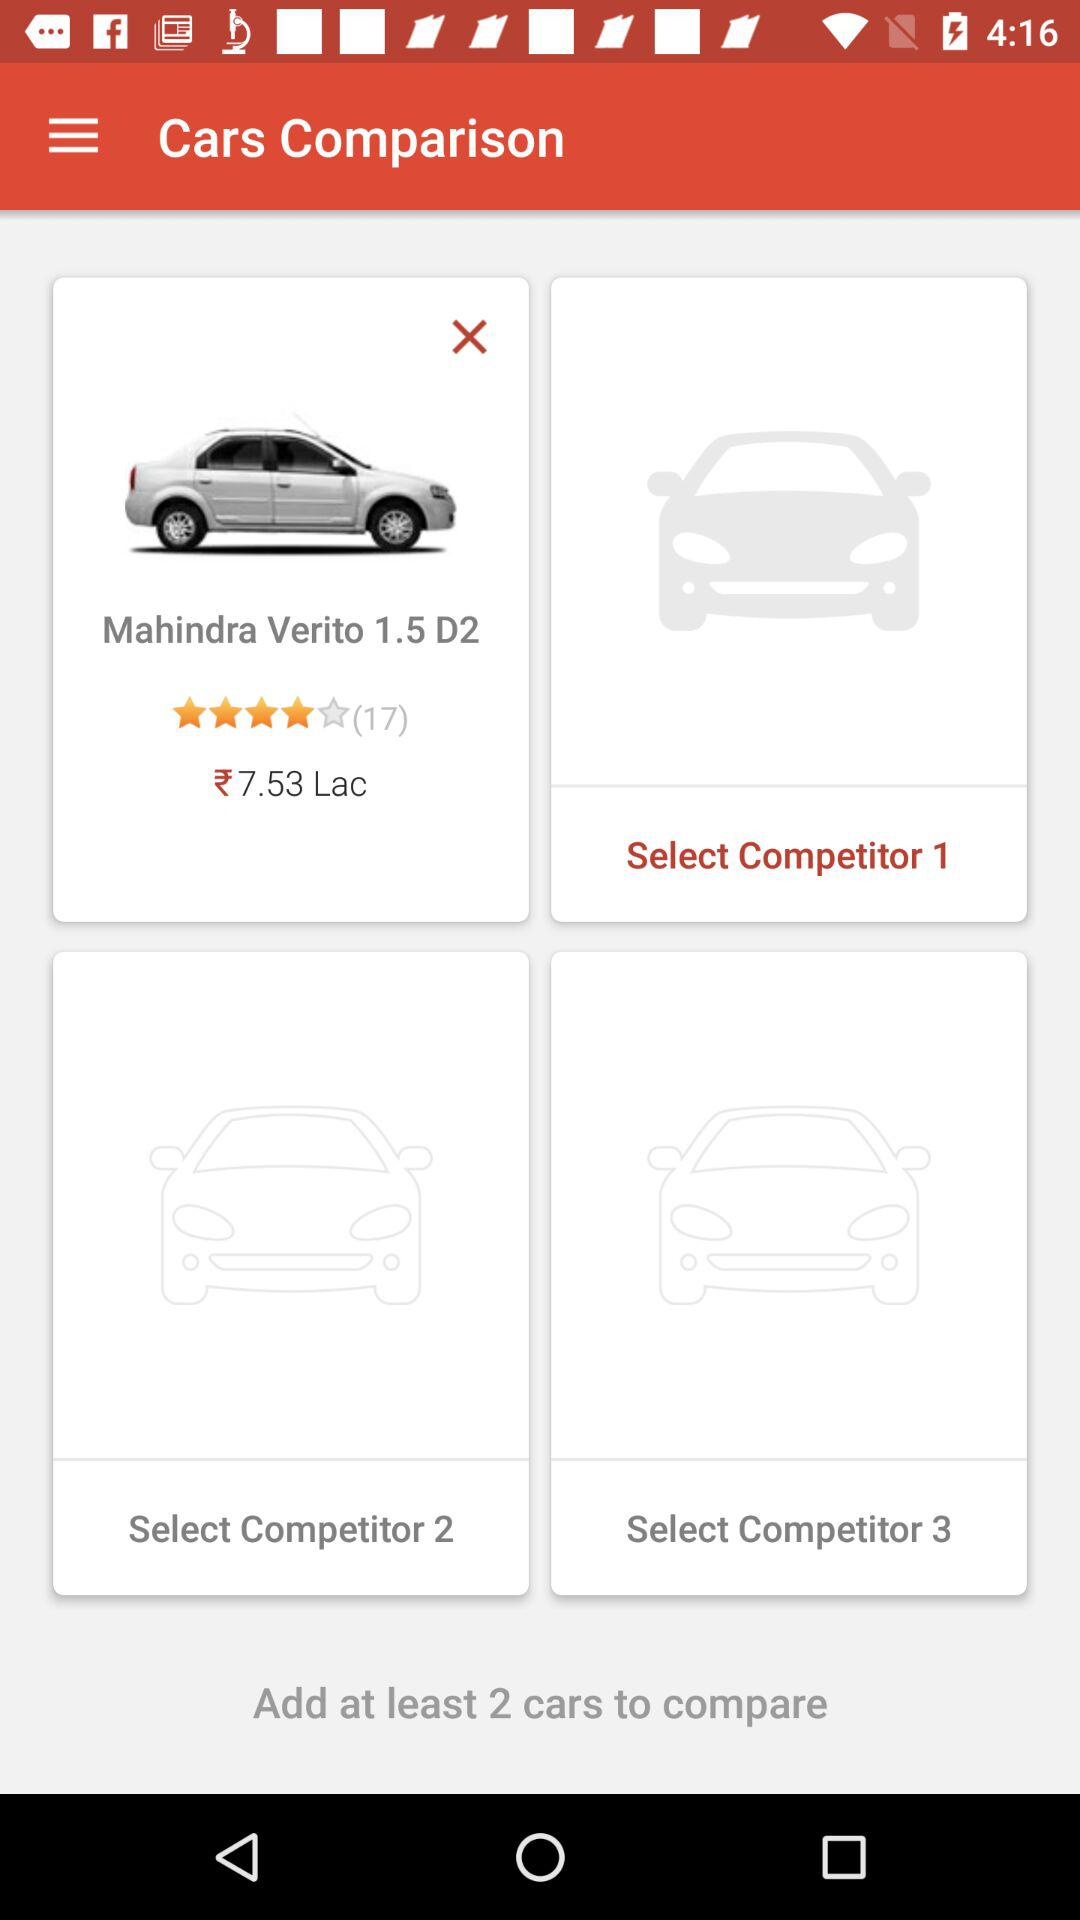What is the model of the Mahindra Verito? The model of the Mahindra Verito is 1.5 D2. 